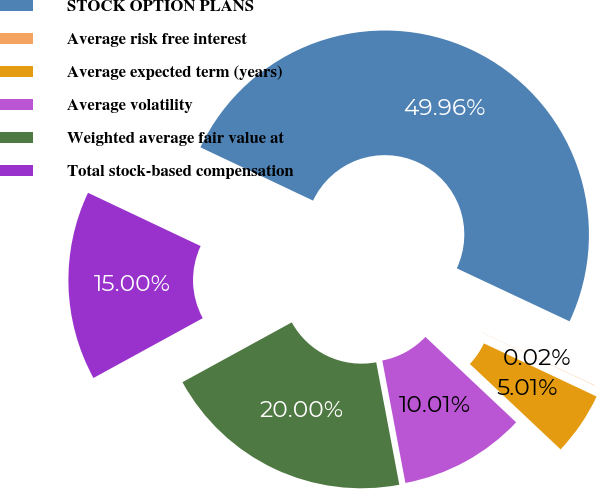<chart> <loc_0><loc_0><loc_500><loc_500><pie_chart><fcel>STOCK OPTION PLANS<fcel>Average risk free interest<fcel>Average expected term (years)<fcel>Average volatility<fcel>Weighted average fair value at<fcel>Total stock-based compensation<nl><fcel>49.96%<fcel>0.02%<fcel>5.01%<fcel>10.01%<fcel>20.0%<fcel>15.0%<nl></chart> 